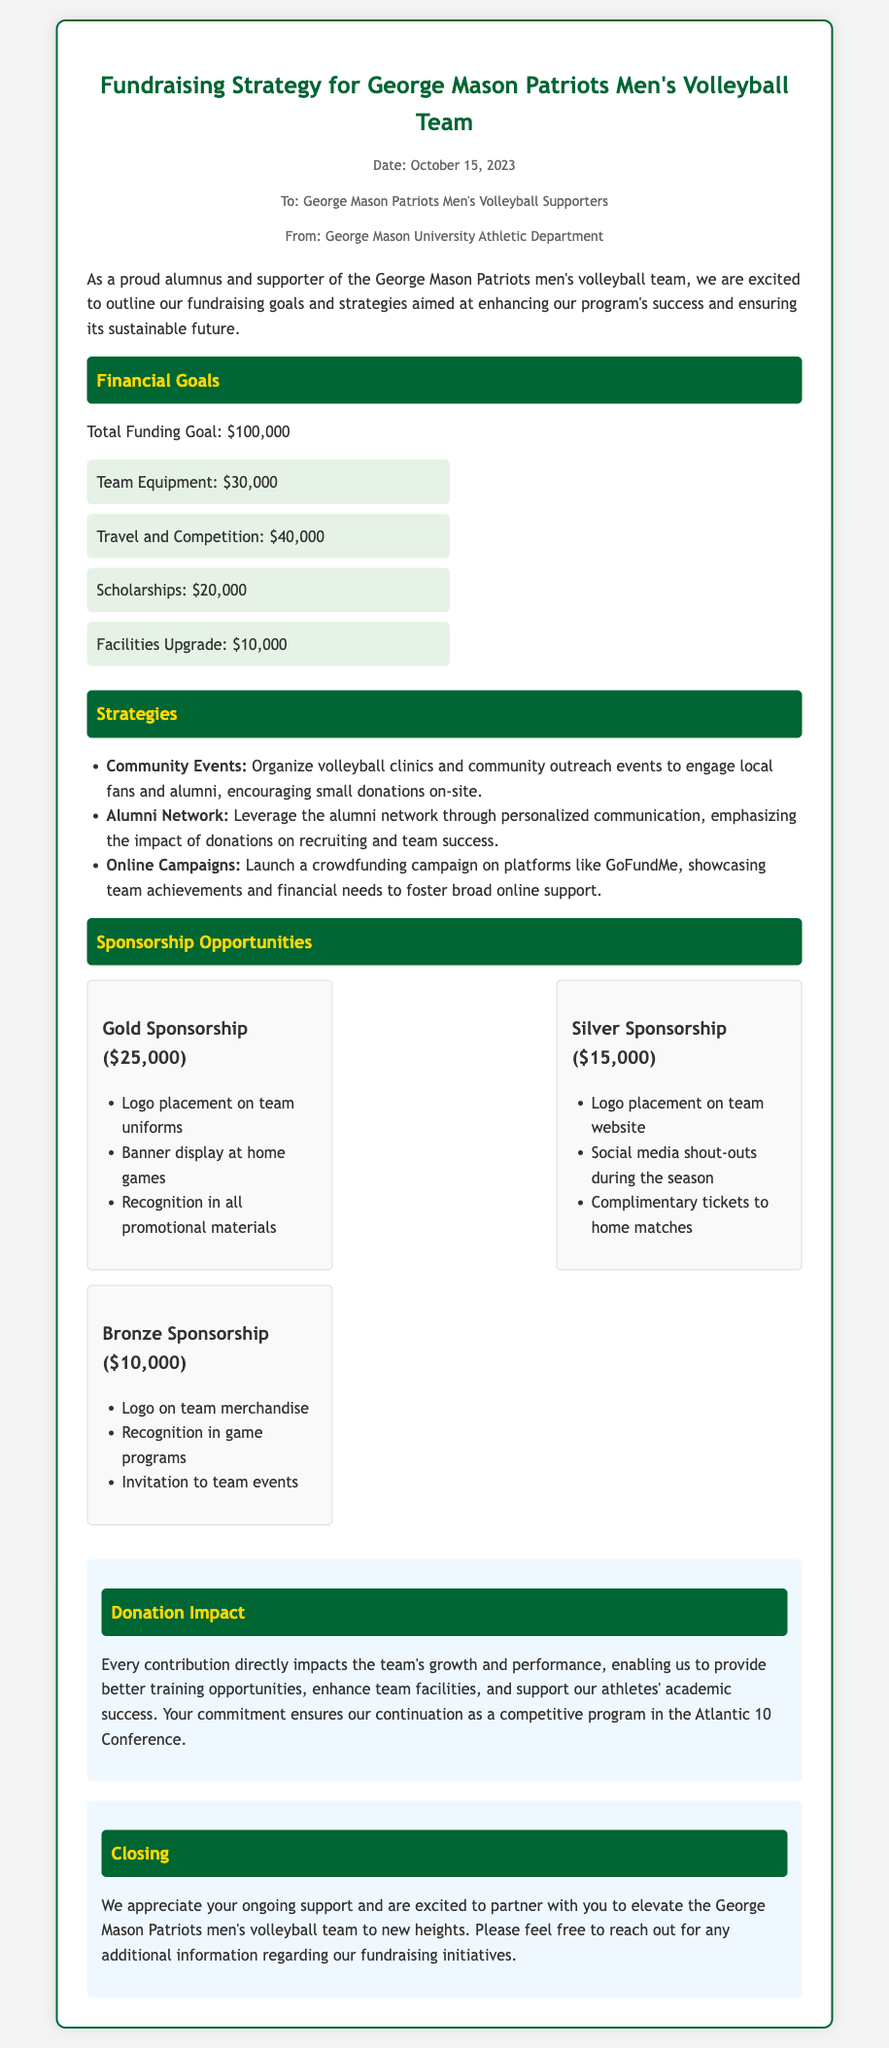what is the total funding goal? The total funding goal is stated clearly in the document.
Answer: $100,000 how much is allocated for team equipment? The document specifies the amount allocated for team equipment as part of the financial goals.
Answer: $30,000 which sponsorship level requires a $15,000 contribution? The document lists different sponsorship levels and their respective contributions.
Answer: Silver Sponsorship what are the three types of sponsorships mentioned? The document outlines three different sponsorship levels and their benefits.
Answer: Gold, Silver, Bronze what is one strategy mentioned for raising funds? The document details several strategies under a specific heading.
Answer: Community Events how much funding is designated for scholarships? The allocation for scholarships is clearly listed in the funding goals section of the document.
Answer: $20,000 what is the impact of donations according to the memo? The document describes the impact of contributions in a dedicated section.
Answer: Team's growth and performance who is the memo addressed to? The opening section of the document specifies the audience for the memo.
Answer: George Mason Patriots Men's Volleyball Supporters 